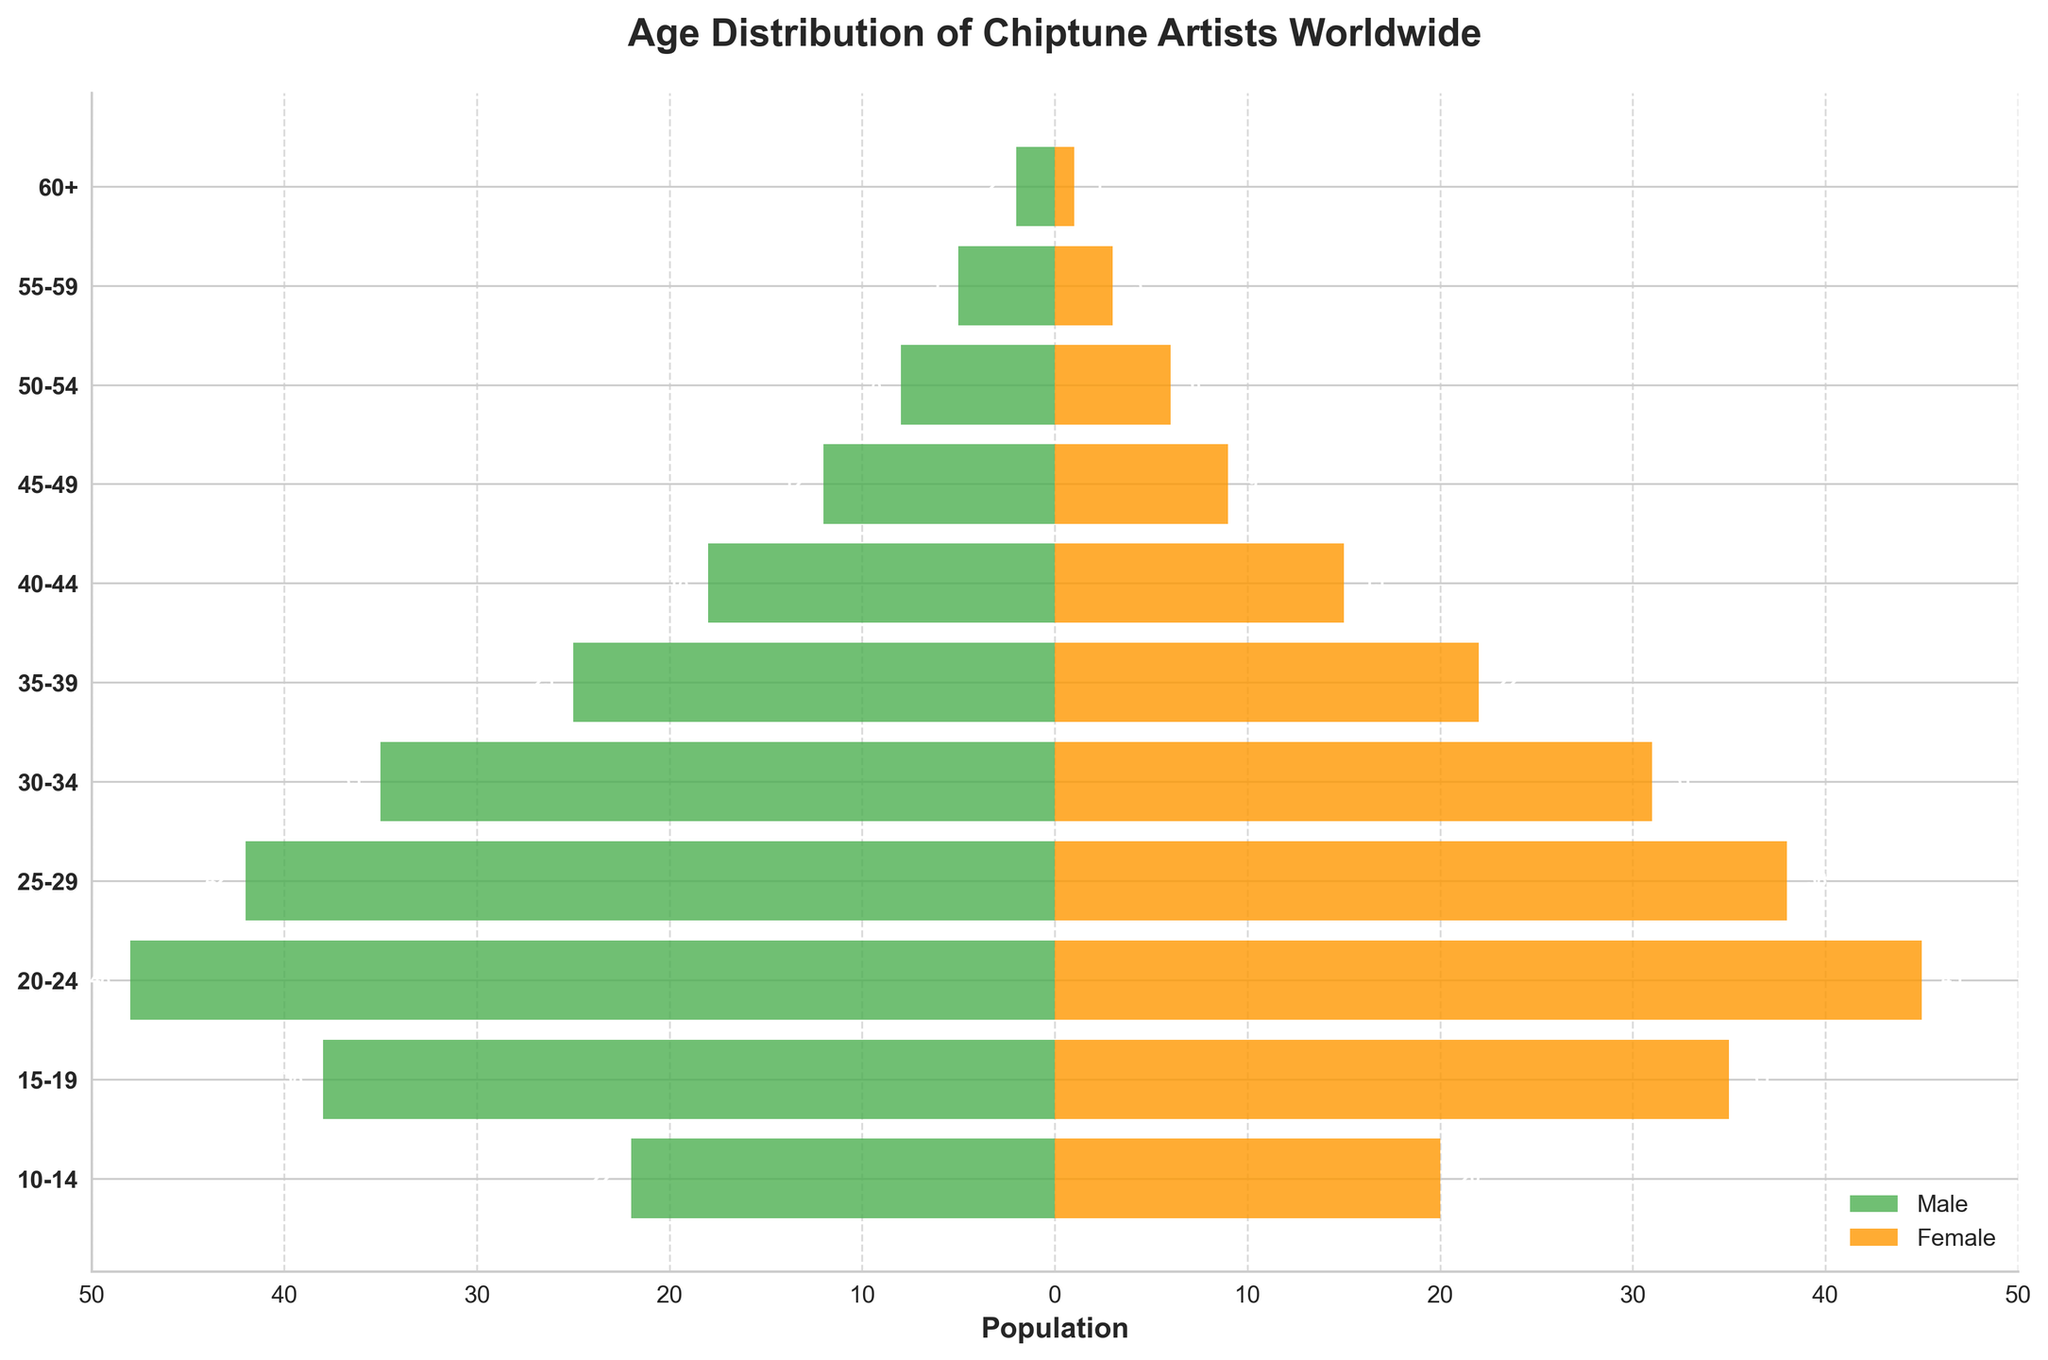What's the title of the plot? The title is displayed at the top of the plot. It reads "Age Distribution of Chiptune Artists Worldwide."
Answer: Age Distribution of Chiptune Artists Worldwide How many age groups are represented in the plot? Each horizontal bar represents an age group. By counting the number of horizontal bars, we get 11 age groups.
Answer: 11 What is the female population in the 25-29 age group? Locate the bar for the 25-29 age group. The length of the orange bar (female population) is 38.
Answer: 38 Which age group has the highest male population? Look at the green bars (male population) to find the longest one. The longest green bar is for the 20-24 age group, with a population of 48.
Answer: 20-24 What is the average female population across all age groups? Sum the female populations and divide by the number of age groups. Sum: 1 + 3 + 6 + 9 + 15 + 22 + 31 + 38 + 45 + 35 + 20 = 225. Average: 225 / 11 = 20.45.
Answer: 20.45 Which gender and age group combination shows a population of 31? The only population value of 31 corresponds to the female population in the 30-34 age group.
Answer: Female, 30-34 